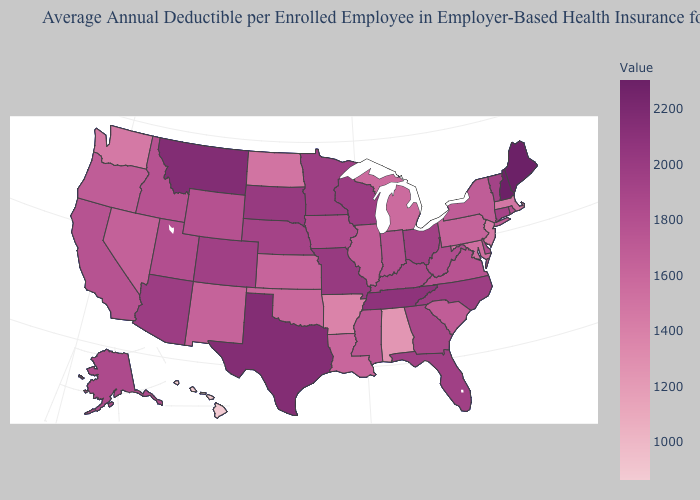Does Hawaii have the lowest value in the USA?
Concise answer only. Yes. Which states hav the highest value in the South?
Keep it brief. Texas. Does Arkansas have a lower value than Hawaii?
Be succinct. No. Among the states that border Rhode Island , which have the highest value?
Answer briefly. Connecticut. Is the legend a continuous bar?
Answer briefly. Yes. Does South Dakota have a lower value than New Hampshire?
Keep it brief. Yes. Does Idaho have the highest value in the West?
Quick response, please. No. 